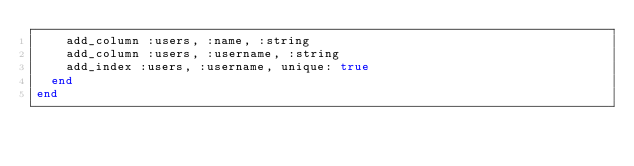<code> <loc_0><loc_0><loc_500><loc_500><_Ruby_>    add_column :users, :name, :string
    add_column :users, :username, :string
    add_index :users, :username, unique: true
  end
end
</code> 